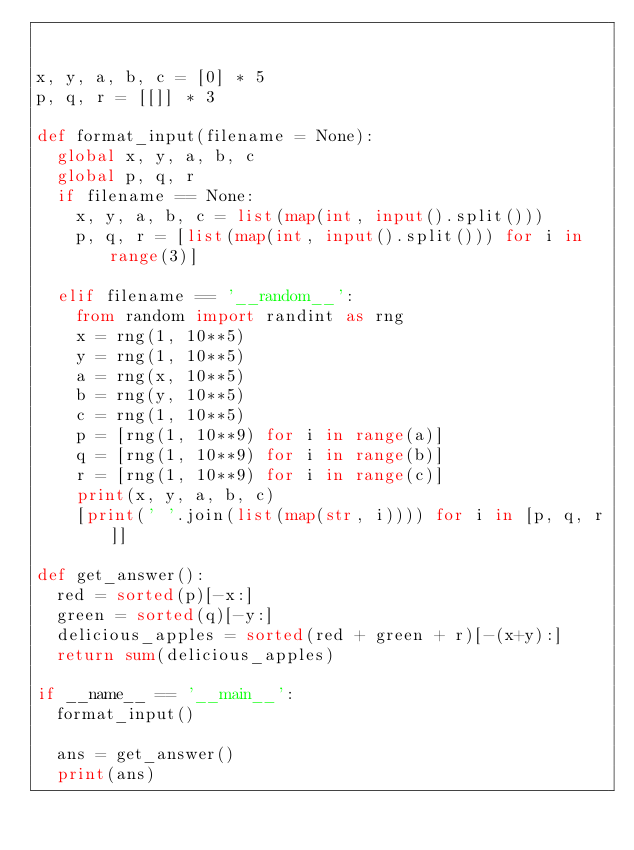<code> <loc_0><loc_0><loc_500><loc_500><_Python_>

x, y, a, b, c = [0] * 5
p, q, r = [[]] * 3

def format_input(filename = None):
	global x, y, a, b, c
	global p, q, r
	if filename == None:
		x, y, a, b, c = list(map(int, input().split()))
		p, q, r = [list(map(int, input().split())) for i in range(3)]

	elif filename == '__random__':
		from random import randint as rng
		x = rng(1, 10**5)
		y = rng(1, 10**5)
		a = rng(x, 10**5)
		b = rng(y, 10**5)
		c = rng(1, 10**5)
		p = [rng(1, 10**9) for i in range(a)]
		q = [rng(1, 10**9) for i in range(b)]
		r = [rng(1, 10**9) for i in range(c)]
		print(x, y, a, b, c)
		[print(' '.join(list(map(str, i)))) for i in [p, q, r]]

def get_answer():
	red = sorted(p)[-x:]
	green = sorted(q)[-y:]
	delicious_apples = sorted(red + green + r)[-(x+y):]
	return sum(delicious_apples)

if __name__ == '__main__':
	format_input()

	ans = get_answer()
	print(ans)
</code> 